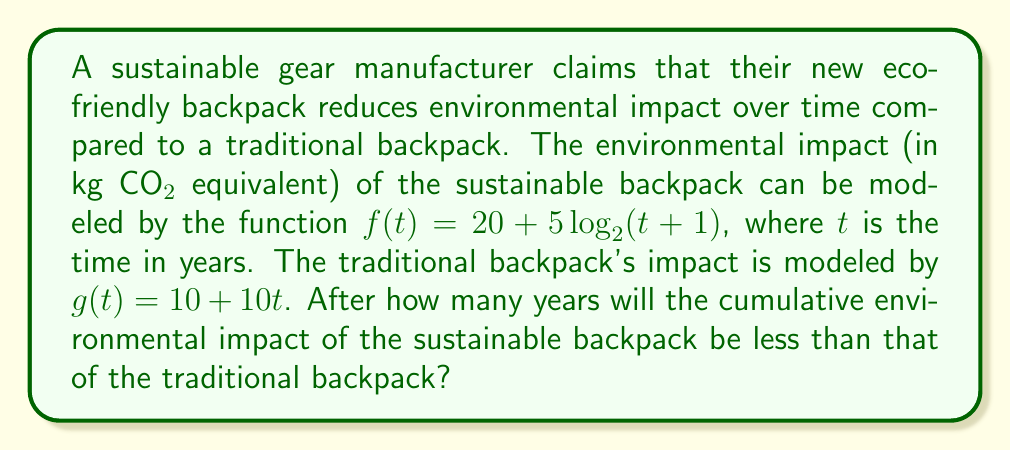Teach me how to tackle this problem. To solve this problem, we need to compare the cumulative environmental impact of both backpacks over time. Let's approach this step-by-step:

1) First, we need to find the cumulative impact functions by integrating $f(t)$ and $g(t)$ from 0 to $t$:

   For the sustainable backpack:
   $$F(t) = \int_0^t (20 + 5\log_2(x+1)) dx = 20t + 5t\log_2(t+1) - 5(t+1)\log_2(e) + 5$$

   For the traditional backpack:
   $$G(t) = \int_0^t (10 + 10x) dx = 10t + 5t^2$$

2) We want to find when $F(t) < G(t)$. Let's set up the inequality:

   $$20t + 5t\log_2(t+1) - 5(t+1)\log_2(e) + 5 < 10t + 5t^2$$

3) Simplify:

   $$5t\log_2(t+1) - 5(t+1)\log_2(e) + 5 < 5t^2 - 10t$$

4) This inequality is complex and doesn't have a simple algebraic solution. We need to use numerical methods or graphing to find the solution.

5) Using a graphing calculator or computer algebra system, we can find that the solution is approximately $t ≈ 3.22$ years.

6) Since we're dealing with whole years, we round up to 4 years.

This means that after 4 years, the cumulative environmental impact of the sustainable backpack will be less than that of the traditional backpack.
Answer: 4 years 